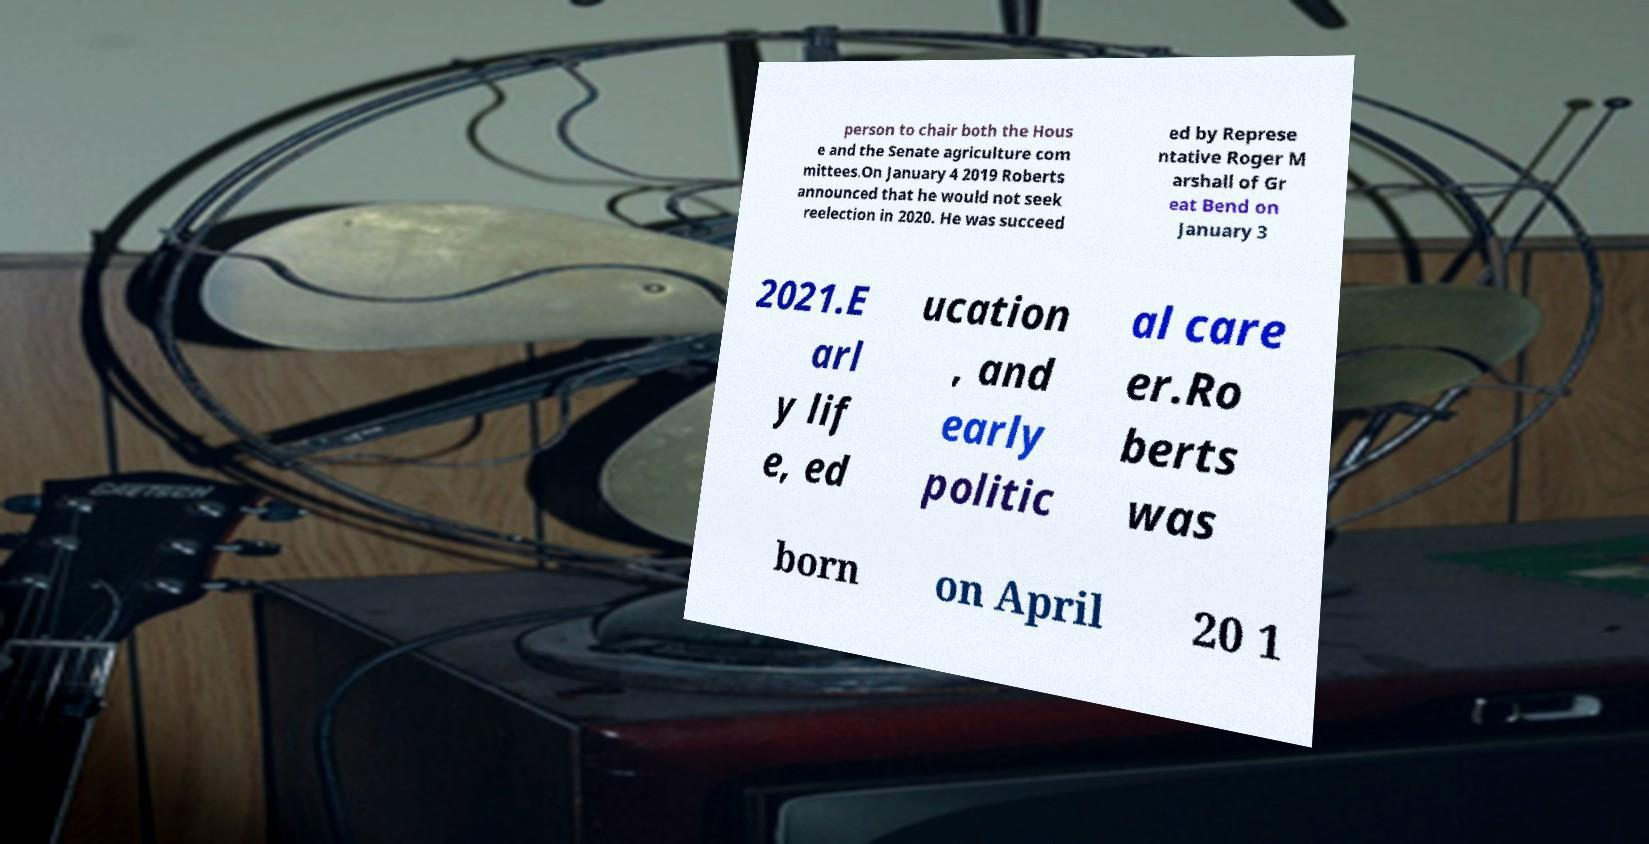Please identify and transcribe the text found in this image. person to chair both the Hous e and the Senate agriculture com mittees.On January 4 2019 Roberts announced that he would not seek reelection in 2020. He was succeed ed by Represe ntative Roger M arshall of Gr eat Bend on January 3 2021.E arl y lif e, ed ucation , and early politic al care er.Ro berts was born on April 20 1 